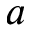Convert formula to latex. <formula><loc_0><loc_0><loc_500><loc_500>a</formula> 